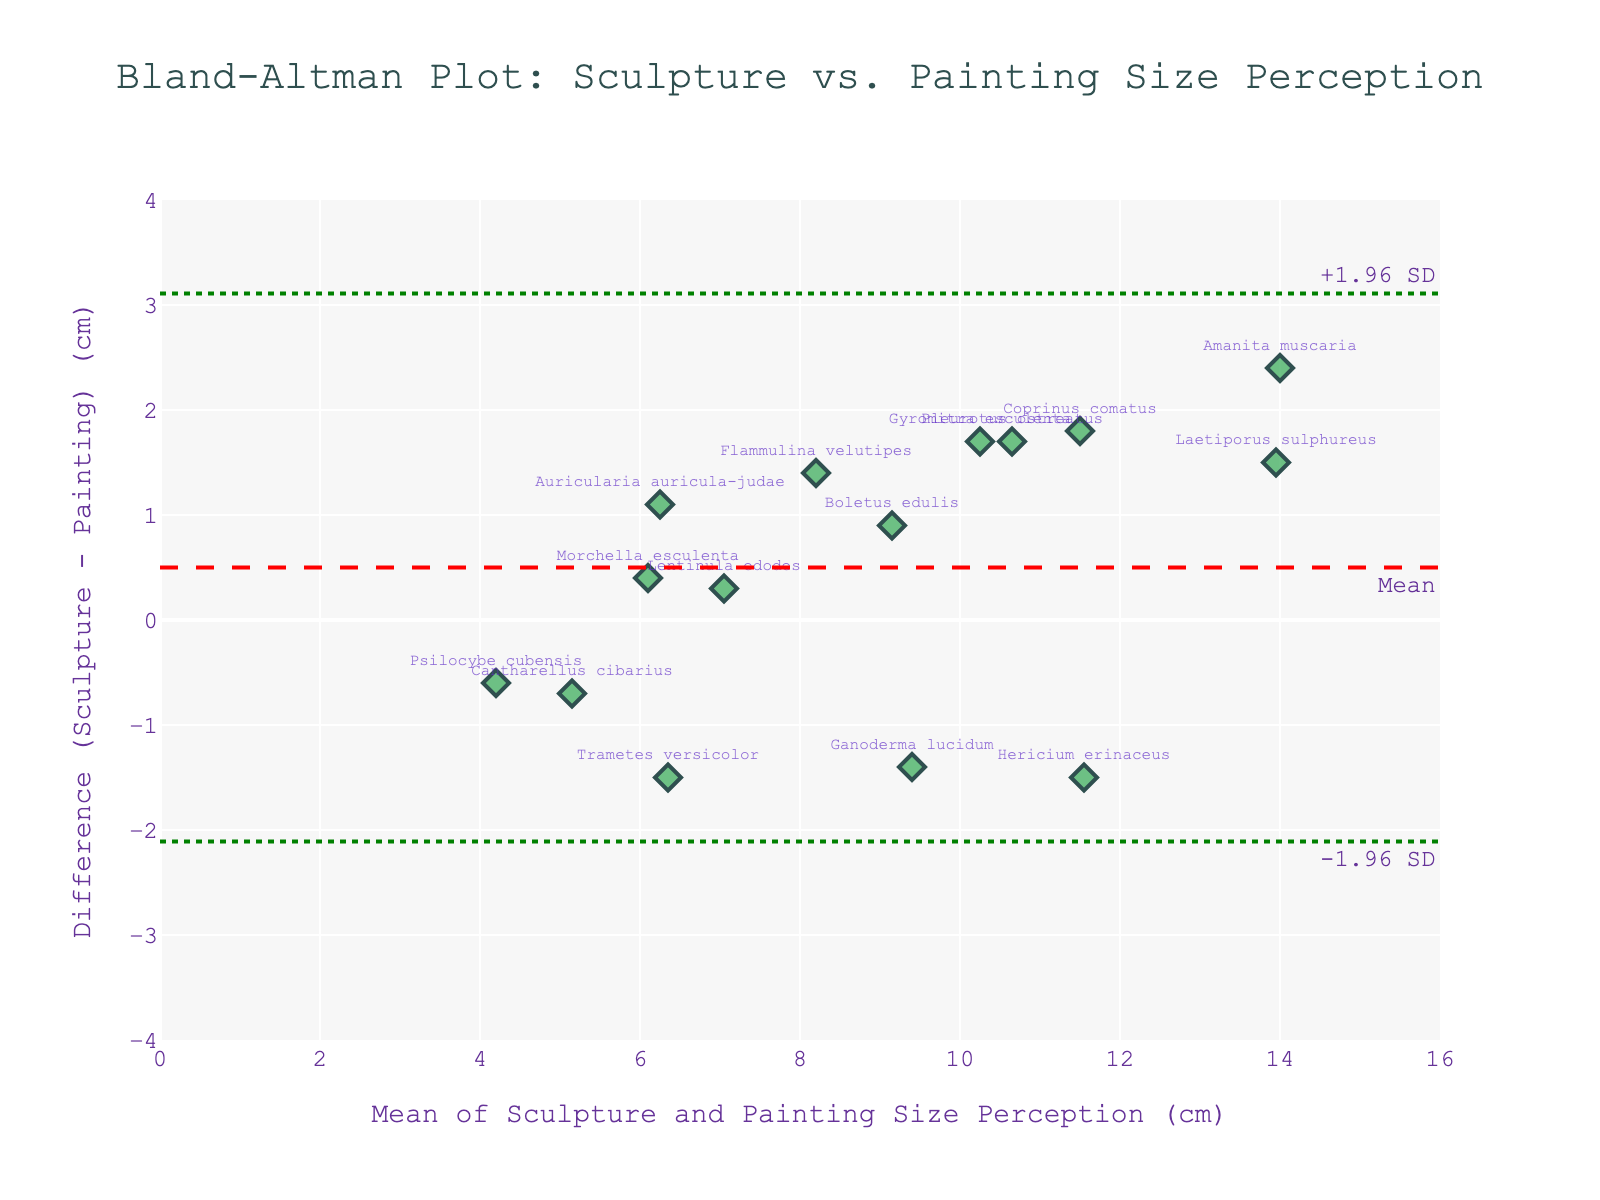What is the title of the plot? The title of the plot is typically located at the top center. By reading the title, you can understand the context and the comparison being made.
Answer: Bland-Altman Plot: Sculpture vs. Painting Size Perception How many data points are displayed in the plot? To determine the number of data points, count the markers (diamonds) in the plot. Each marker represents a comparison of sizes for different mushroom species between sculpture and painting.
Answer: 15 What is the range of the x-axis? To find the range of the x-axis, look at the numbers labeled on the horizontal axis. The x-axis represents the mean size perception of mushrooms in sculptures and paintings.
Answer: 0 to 16 What is the mean difference between sculpture and painting size perception? The mean difference is indicated by a dashed red line on the y-axis, often with an annotation. This line represents the average of all the differences between sculpture and painting size perceptions.
Answer: ~0.4 cm Which mushroom species has the largest positive difference between sculpture and painting size perception? To find this, look for the point that is farthest above the horizontal axis on the plot. Identify the mushroom species labeled near this point.
Answer: Pleurotus ostreatus What are the upper and lower limits of agreement in the plot? The upper and lower limits of agreement are shown as dotted green lines on the plot. These lines represent the mean difference plus and minus 1.96 times the standard deviation of the differences.
Answer: ~2.9 cm and ~-2.1 cm Which mushroom species has the closest mean size perception between sculpture and painting? Look for the marker that is closest to the horizontal axis at zero difference. The label near this marker indicates the species.
Answer: Laetiporus sulphureus What is the color used for the markers representing mushroom species? Identify the color of the markers by observing them directly in the plot. They are the colored shapes representing data points.
Answer: Green Are there more points above or below the mean difference line? Observe the number of points above and below the red dashed line, which represents the mean difference, to determine the distribution of data points.
Answer: Below 